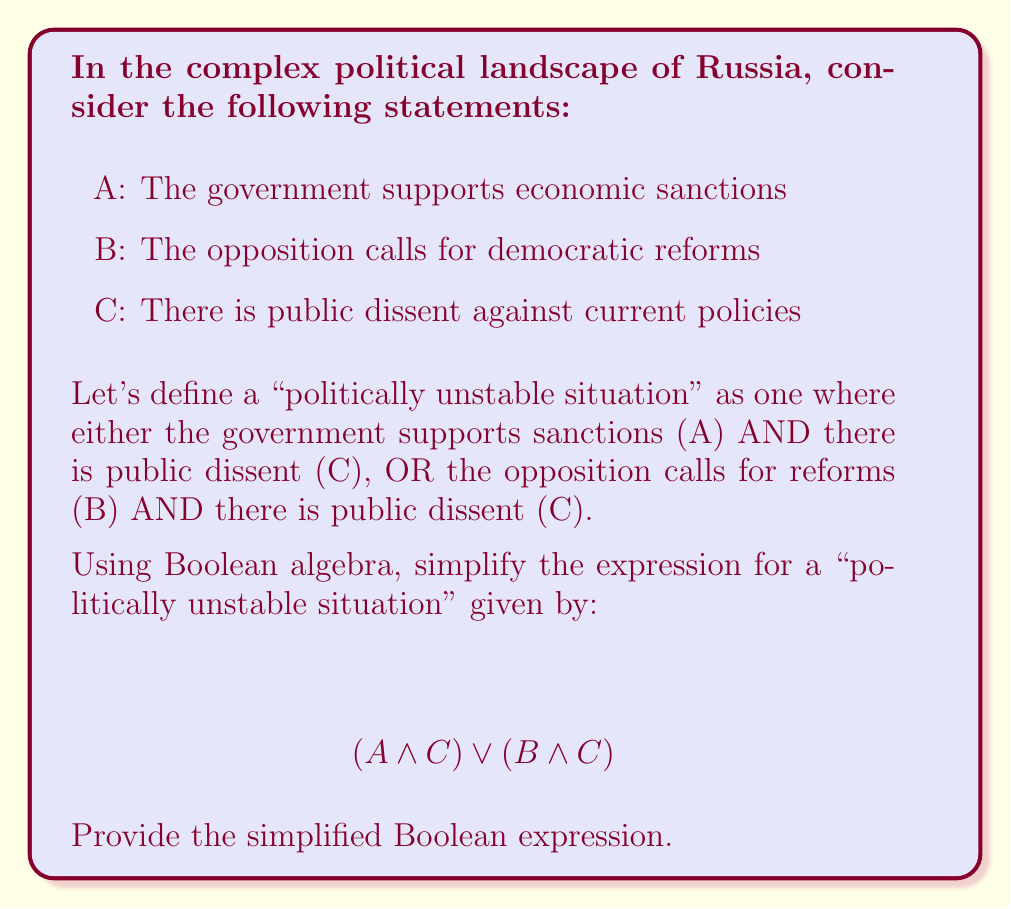Can you solve this math problem? Let's simplify this expression step by step using Boolean algebra laws:

1) Start with the given expression:
   $$(A \land C) \lor (B \land C)$$

2) We can factor out C using the distributive law of Boolean algebra:
   $$C \land (A \lor B)$$

3) This is already in its simplest form. We can interpret this as:
   "There is public dissent (C) AND (either the government supports sanctions (A) OR the opposition calls for reforms (B))"

4) We cannot simplify this further without additional information about the relationship between A and B.

5) Note that this simplification reduces the original expression from two AND operations and one OR operation to just one AND operation and one OR operation, making it more concise and easier to analyze.
Answer: $C \land (A \lor B)$ 